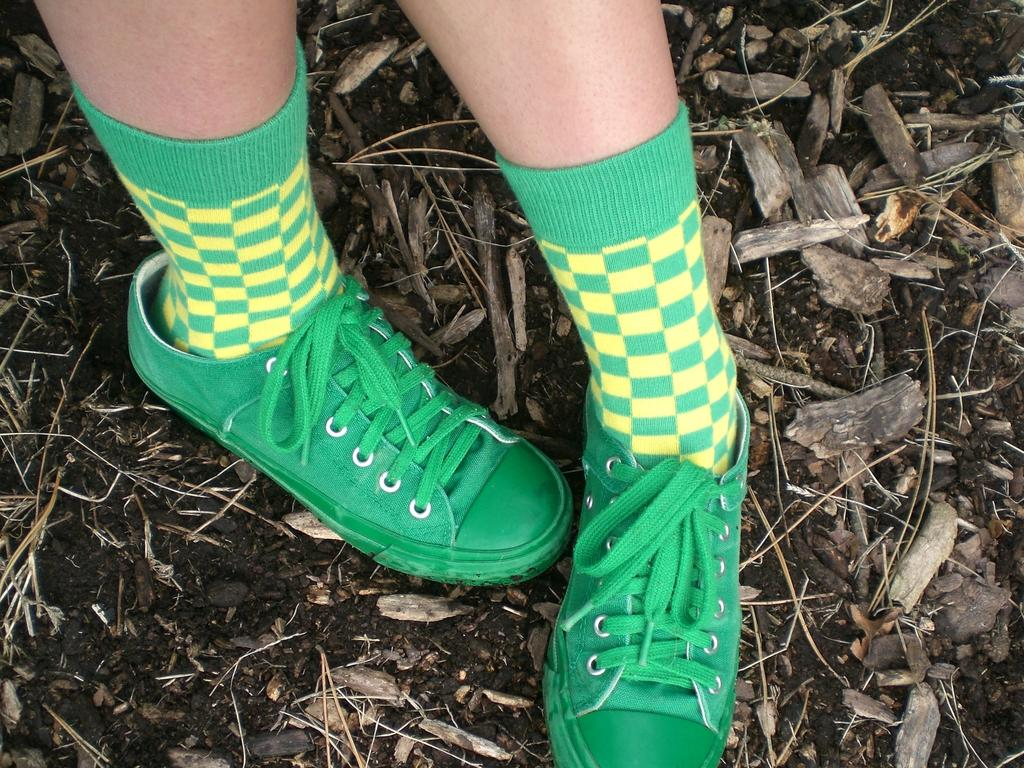What is present in the image? There is a person in the image. What part of the person's body can be seen? The person's legs are visible. What type of footwear is the person wearing? The person is wearing green color shoes. What can be found at the bottom of the image? There are sticks and soil present at the bottom of the image. What type of notebook can be seen on the person's toes in the image? There is no notebook present in the image, and the person's toes are not mentioned in the facts provided. What type of furniture is visible in the image? There is no furniture visible in the image; the facts provided only mention a person, their legs, shoes, and objects at the bottom of the image. 